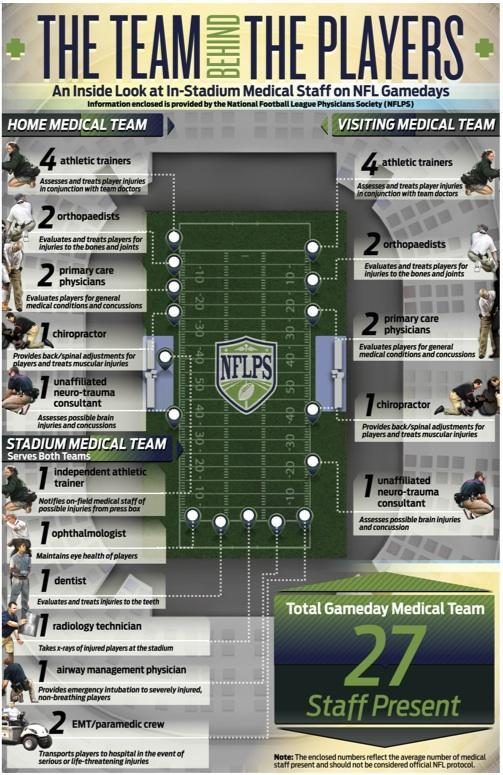How many medical staffs serve in a stadium medical team on NFL game-days?
Answer the question with a short phrase. 7 What is the total number of medical staffs present on an NFL game-day according to NFLPS? 27 Who will access & treats player injuries in conjunction with team doctors on NFL game-days? athletic trainers Who will provide emergency intubation to severely injured, non breathing players on NFL game-days? airway mangement physician What is the responsibility of an ophthalmologist in the stadium medical team? Maintains eye health of players Who will access possible brain injuries and concussions of the players on NFL game-days? unaffiliated neuro-trauma consultant How many primary care physicians will be there in the home medical team as per the NFLPS? 2 How many medical staffs serve in a home medical team on NFL game-days? 10 